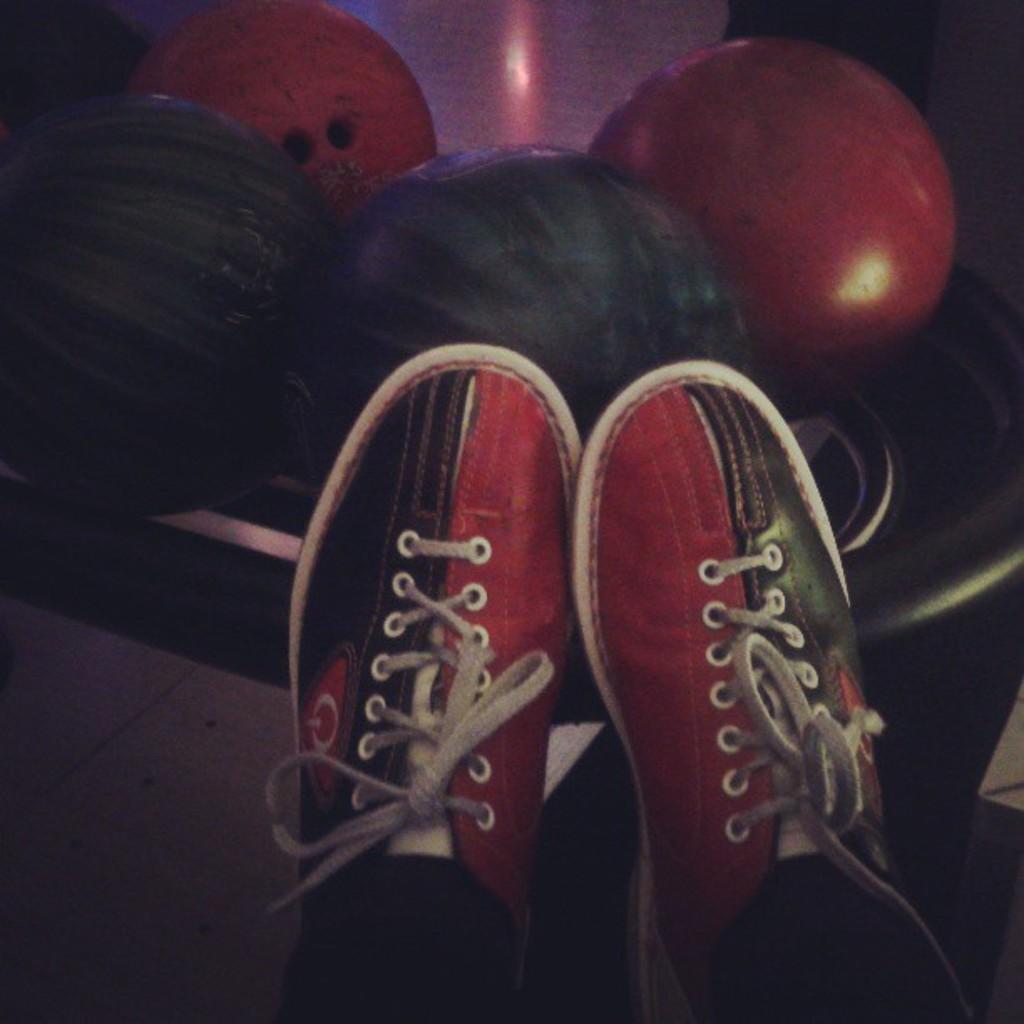Describe this image in one or two sentences. In this image there is a pair of shoes. Behind the shoes there are balls on the floor. 